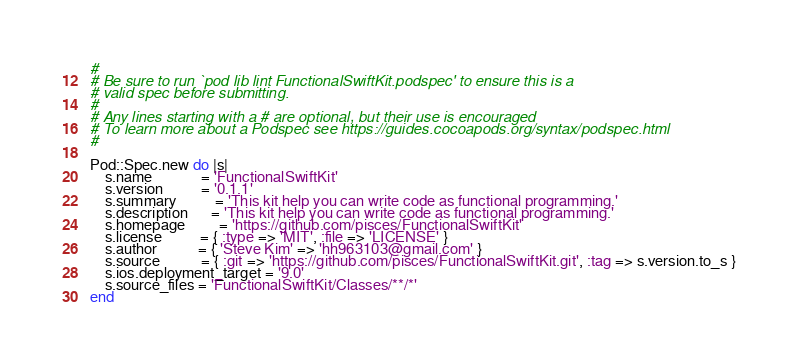<code> <loc_0><loc_0><loc_500><loc_500><_Ruby_>#
# Be sure to run `pod lib lint FunctionalSwiftKit.podspec' to ensure this is a
# valid spec before submitting.
#
# Any lines starting with a # are optional, but their use is encouraged
# To learn more about a Podspec see https://guides.cocoapods.org/syntax/podspec.html
#

Pod::Spec.new do |s|
    s.name             = 'FunctionalSwiftKit'
    s.version          = '0.1.1'
    s.summary          = 'This kit help you can write code as functional programming.'
    s.description      = 'This kit help you can write code as functional programming.'
    s.homepage         = 'https://github.com/pisces/FunctionalSwiftKit'
    s.license          = { :type => 'MIT', :file => 'LICENSE' }
    s.author           = { 'Steve Kim' => 'hh963103@gmail.com' }
    s.source           = { :git => 'https://github.com/pisces/FunctionalSwiftKit.git', :tag => s.version.to_s }
    s.ios.deployment_target = '9.0'
    s.source_files = 'FunctionalSwiftKit/Classes/**/*'
end
</code> 